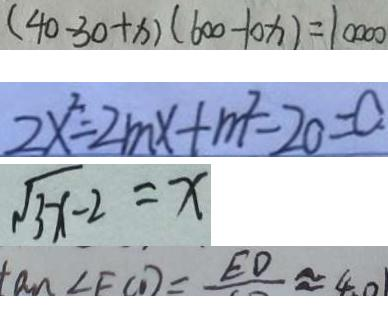Convert formula to latex. <formula><loc_0><loc_0><loc_500><loc_500>( 4 0 - 3 0 + x ) ( 6 0 0 - 1 0 x ) = 1 0 0 0 0 
 2 x ^ { 2 } = 2 m x + m ^ { 2 } - 2 0 = 0 . 
 \sqrt { 3 x - 2 } = x 
 \tan \angle F C D = E D \approx 4 0</formula> 